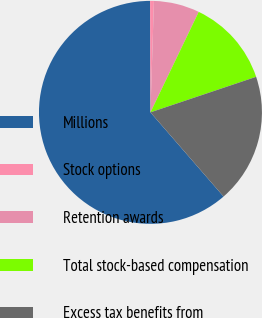Convert chart to OTSL. <chart><loc_0><loc_0><loc_500><loc_500><pie_chart><fcel>Millions<fcel>Stock options<fcel>Retention awards<fcel>Total stock-based compensation<fcel>Excess tax benefits from<nl><fcel>61.33%<fcel>0.55%<fcel>6.63%<fcel>12.71%<fcel>18.78%<nl></chart> 